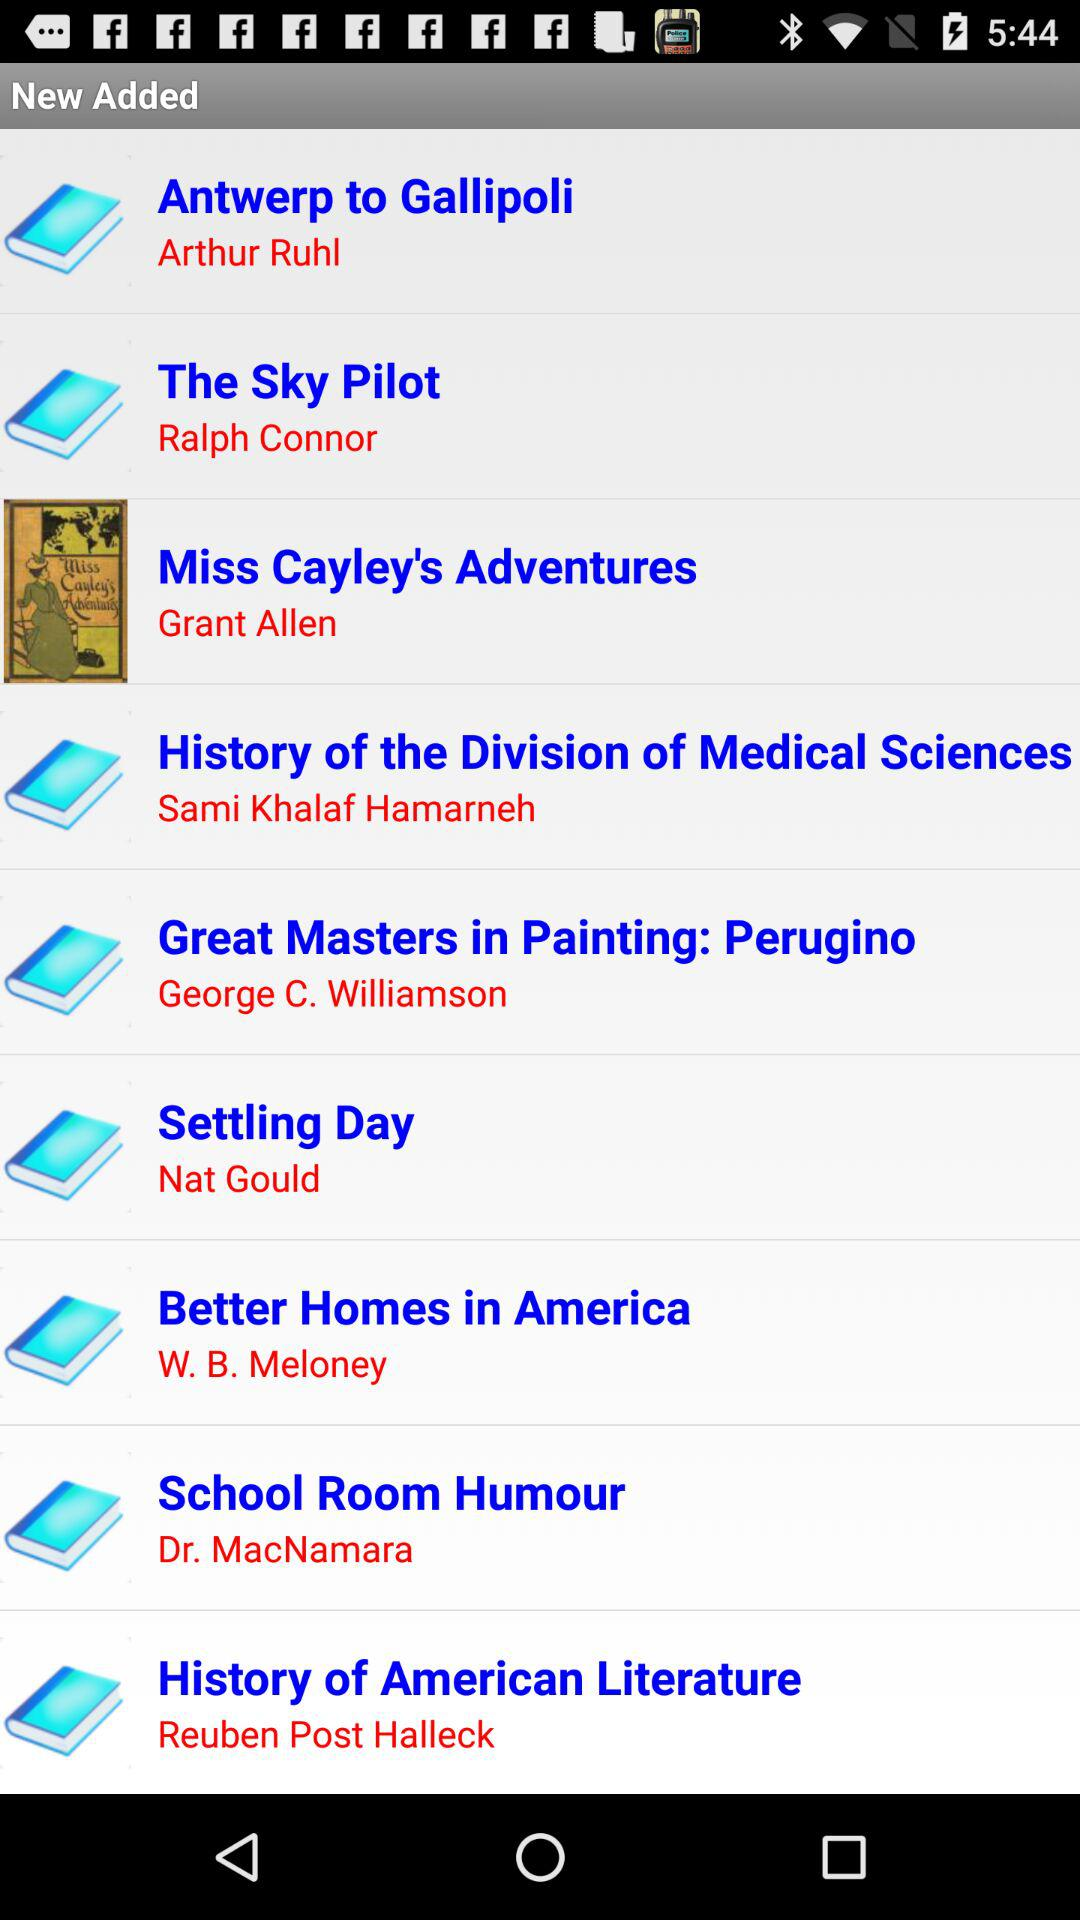Who is the author of the book School Room Humour? The author of the book is Dr. MacNamara. 